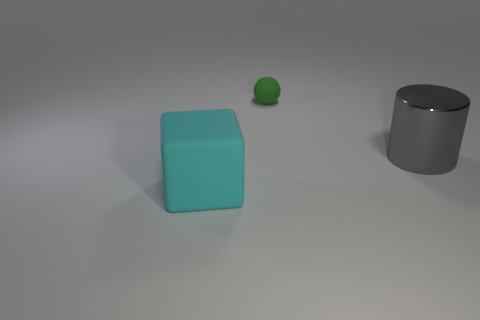How do the textures of the three different objects compare? The cyan cube and the gray cylinder have relatively smooth textures suggesting they are made of materials like plastic and metal respectively. The small green sphere has a slightly textured surface, which might indicate a matte finish, possibly made of rubber or a similar material. 